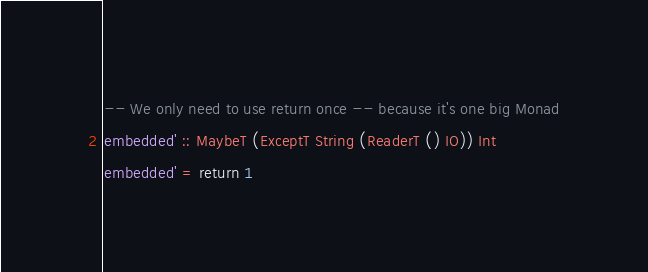Convert code to text. <code><loc_0><loc_0><loc_500><loc_500><_Haskell_>-- We only need to use return once -- because it's one big Monad
embedded' :: MaybeT (ExceptT String (ReaderT () IO)) Int
embedded' = return 1
</code> 